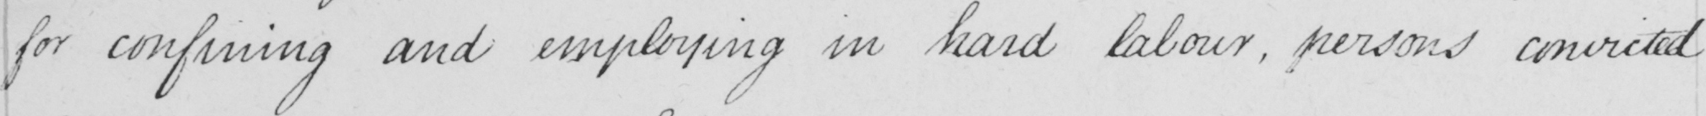What is written in this line of handwriting? for confining and employing in hard labour , person convicted 